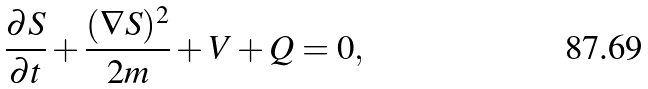<formula> <loc_0><loc_0><loc_500><loc_500>\frac { \partial S } { \partial t } + \frac { ( \nabla S ) ^ { 2 } } { 2 m } + V + Q = 0 ,</formula> 